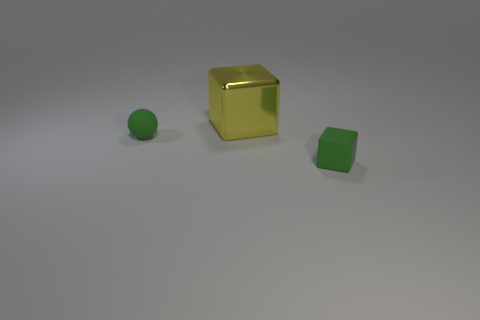Add 1 small rubber cylinders. How many objects exist? 4 Subtract all cubes. How many objects are left? 1 Subtract all small green metal things. Subtract all yellow things. How many objects are left? 2 Add 2 green cubes. How many green cubes are left? 3 Add 1 small metal cylinders. How many small metal cylinders exist? 1 Subtract 0 red cubes. How many objects are left? 3 